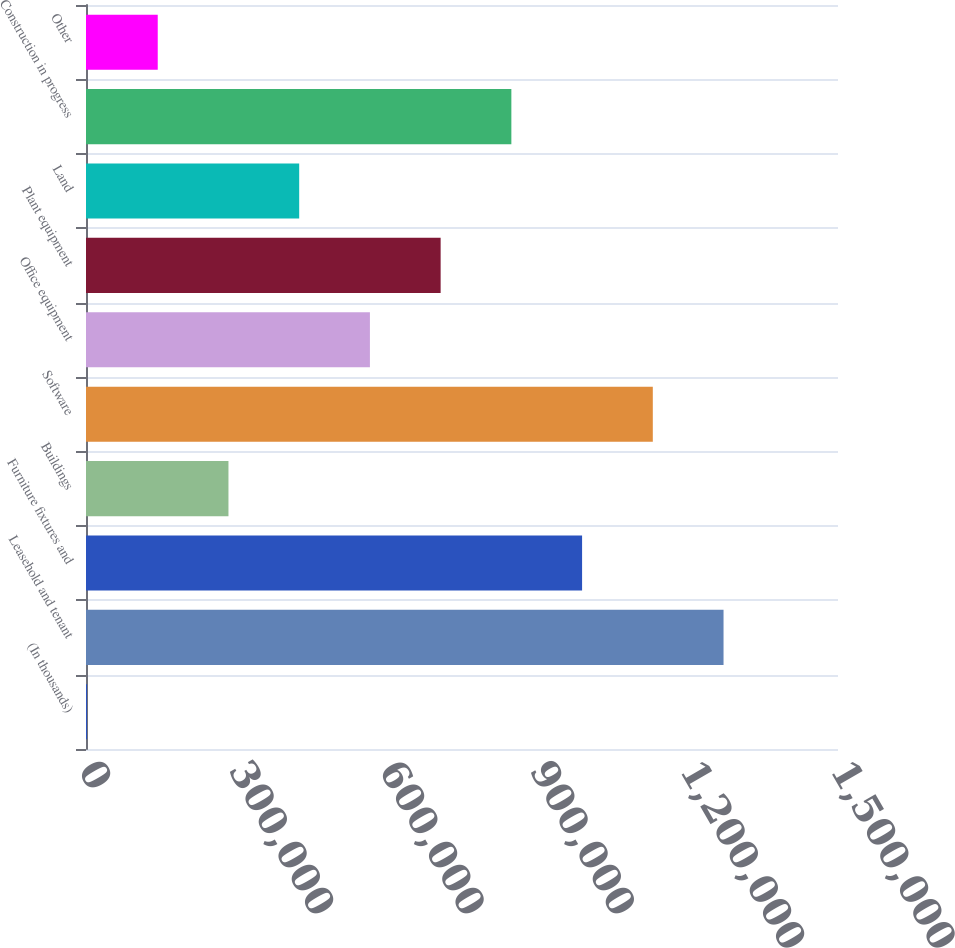Convert chart. <chart><loc_0><loc_0><loc_500><loc_500><bar_chart><fcel>(In thousands)<fcel>Leasehold and tenant<fcel>Furniture fixtures and<fcel>Buildings<fcel>Software<fcel>Office equipment<fcel>Plant equipment<fcel>Land<fcel>Construction in progress<fcel>Other<nl><fcel>2017<fcel>1.27168e+06<fcel>989536<fcel>284165<fcel>1.13061e+06<fcel>566313<fcel>707388<fcel>425239<fcel>848462<fcel>143091<nl></chart> 